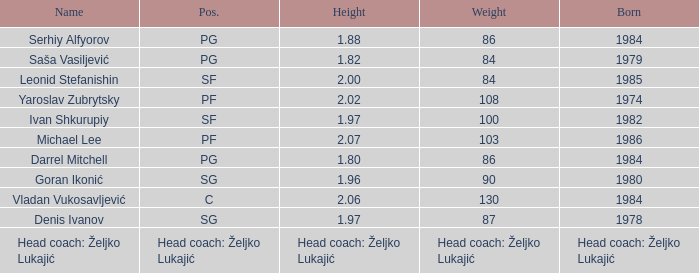What was the heaviness of serhiy alfyorov? 86.0. 